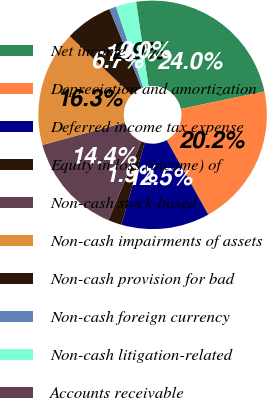Convert chart to OTSL. <chart><loc_0><loc_0><loc_500><loc_500><pie_chart><fcel>Net income<fcel>Depreciation and amortization<fcel>Deferred income tax expense<fcel>Equity in loss (income) of<fcel>Non-cash stock-based<fcel>Non-cash impairments of assets<fcel>Non-cash provision for bad<fcel>Non-cash foreign currency<fcel>Non-cash litigation-related<fcel>Accounts receivable<nl><fcel>24.02%<fcel>20.18%<fcel>12.5%<fcel>1.93%<fcel>14.42%<fcel>16.34%<fcel>6.74%<fcel>0.97%<fcel>2.89%<fcel>0.01%<nl></chart> 